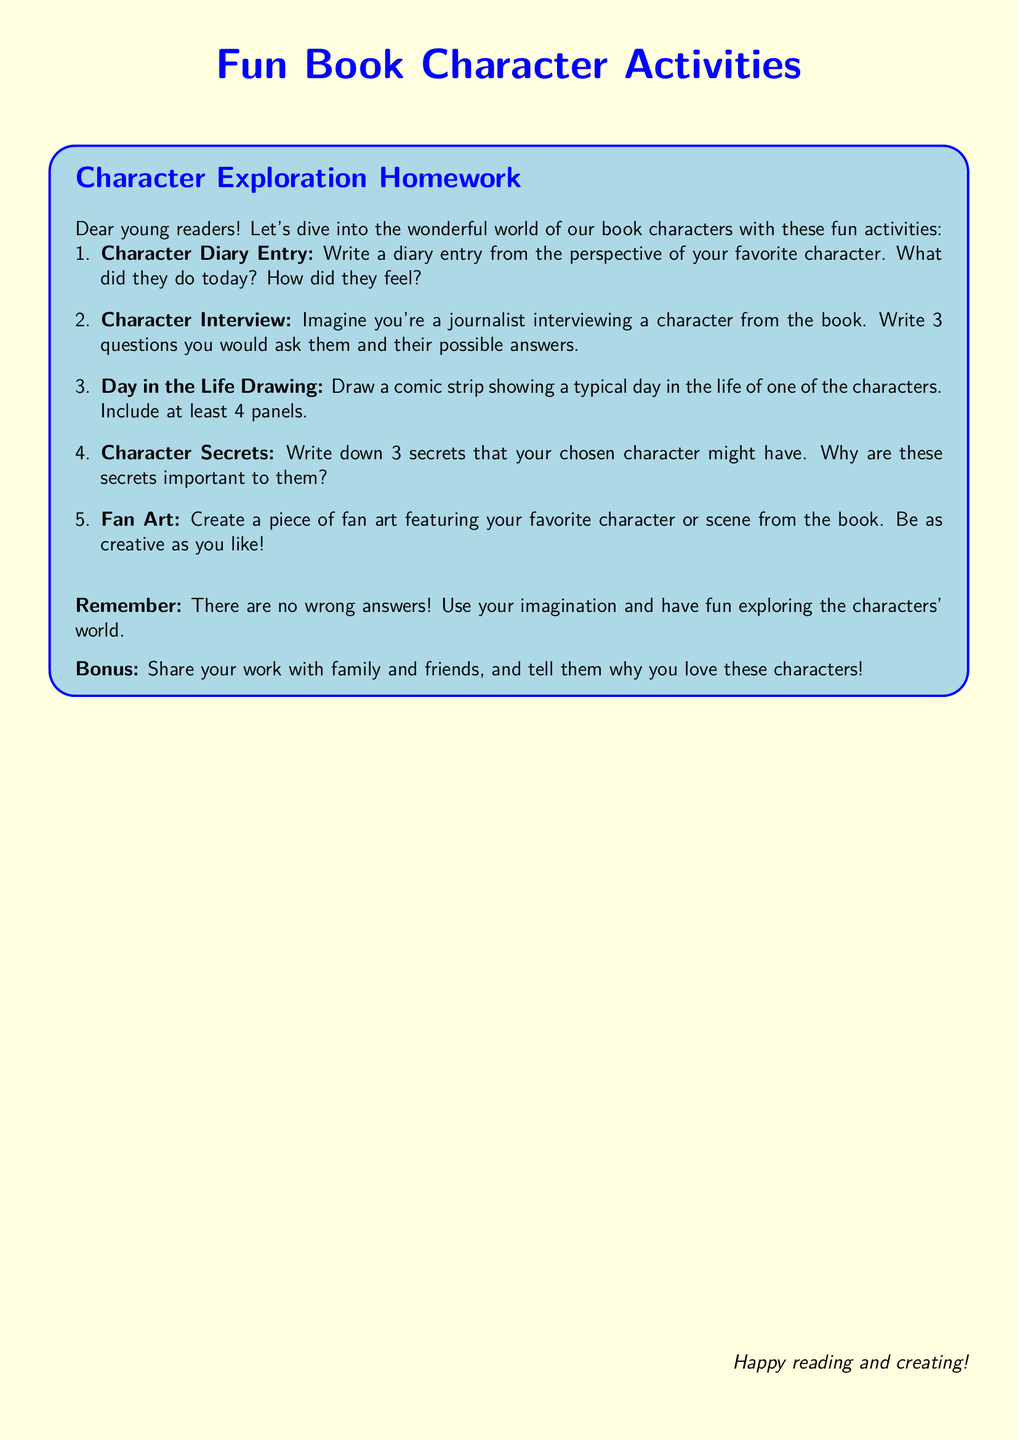What is the title of the document? The title of the document is shown prominently at the top.
Answer: Fun Book Character Activities What color is the background of the document? The background color is specified in the document settings.
Answer: Light yellow How many character activities are listed? The number of activities is indicated in the enumerated list.
Answer: Five Which font is used throughout the document? The font type is set in the document preamble.
Answer: Comic Sans MS What is the primary color used for the title? The color of the title is mentioned specifically in the formatting section.
Answer: Blue What type of activity is a "Character Interview"? The type of activity describes how to engage with a character from the book.
Answer: Imaginary interview What is included in the "Bonus" section? The bonus section suggests an additional action for readers.
Answer: Share your work with family and friends What should the comic strip include? The requirement for the comic strip is specified in the activity instructions.
Answer: At least 4 panels 